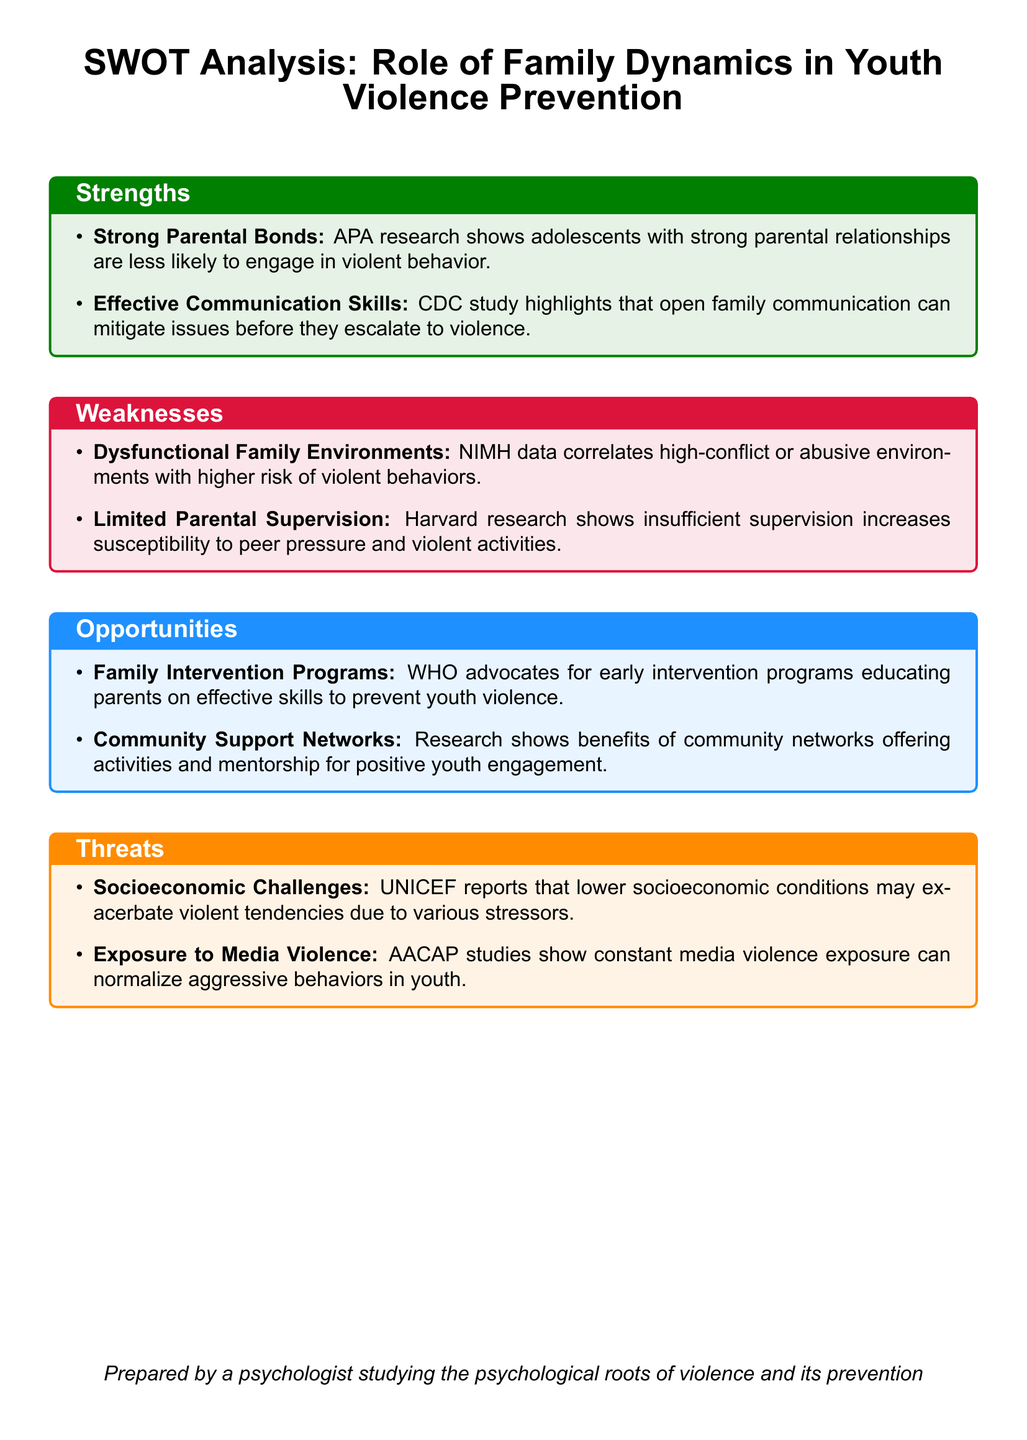what are the strengths identified in the document? The strengths discussed in the document include 'Strong Parental Bonds' and 'Effective Communication Skills'.
Answer: 'Strong Parental Bonds, Effective Communication Skills' which organization advocates for early intervention programs? The document states that WHO advocates for early intervention programs educating parents.
Answer: WHO what correlates with higher risk of violent behaviors? The document mentions that dysfunctional family environments correlate with higher risk of violent behaviors.
Answer: Dysfunctional Family Environments how does limited parental supervision affect youth? According to the document, limited parental supervision increases susceptibility to peer pressure and violent activities.
Answer: Increases susceptibility to peer pressure and violent activities what threat is associated with lower socioeconomic conditions? The document indicates that lower socioeconomic conditions may exacerbate violent tendencies.
Answer: Exacerbate violent tendencies what can constant media violence exposure normalize? The document states that constant media violence exposure can normalize aggressive behaviors in youth.
Answer: Aggressive behaviors in youth how do community support networks benefit youth? Research in the document shows that community support networks offer activities and mentorship for positive youth engagement.
Answer: Activities and mentorship for positive youth engagement which psychological health issue is linked to abusive family environments? The document cites NIMH data linking high-conflict or abusive environments with greater risks for violent behaviors.
Answer: Greater risks for violent behaviors 